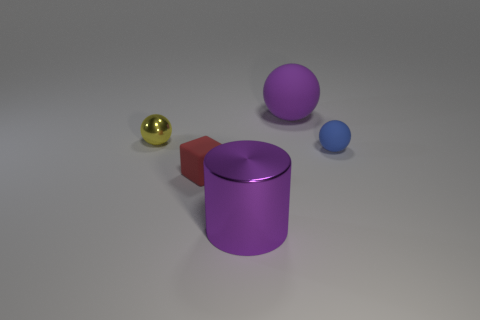Add 2 yellow cylinders. How many objects exist? 7 Subtract all spheres. How many objects are left? 2 Add 5 large purple things. How many large purple things are left? 7 Add 2 large metallic things. How many large metallic things exist? 3 Subtract 1 purple cylinders. How many objects are left? 4 Subtract all large cylinders. Subtract all blue objects. How many objects are left? 3 